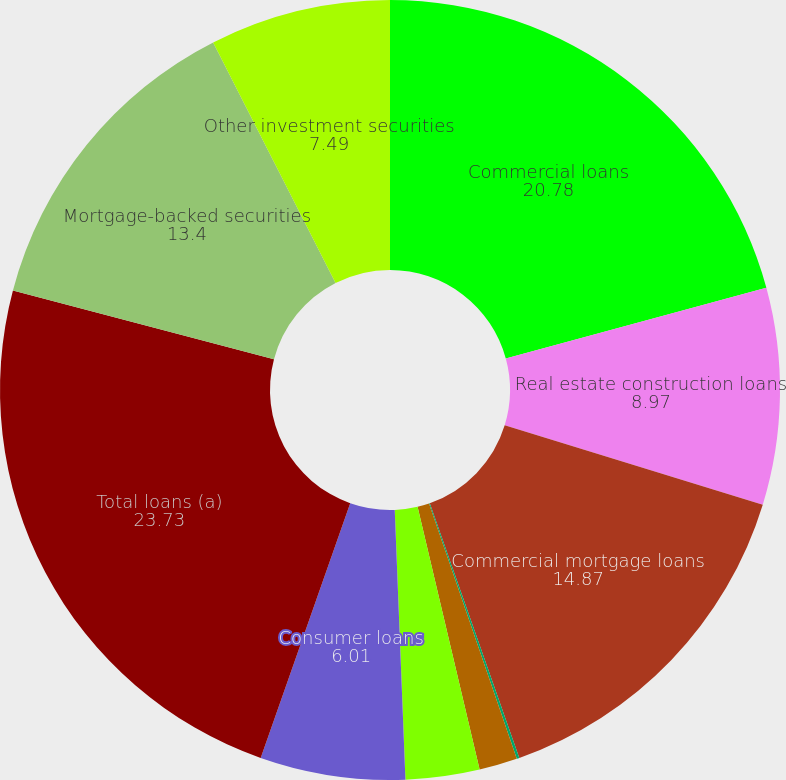Convert chart to OTSL. <chart><loc_0><loc_0><loc_500><loc_500><pie_chart><fcel>Commercial loans<fcel>Real estate construction loans<fcel>Commercial mortgage loans<fcel>Lease financing<fcel>International loans<fcel>Residential mortgage loans<fcel>Consumer loans<fcel>Total loans (a)<fcel>Mortgage-backed securities<fcel>Other investment securities<nl><fcel>20.78%<fcel>8.97%<fcel>14.87%<fcel>0.11%<fcel>1.58%<fcel>3.06%<fcel>6.01%<fcel>23.73%<fcel>13.4%<fcel>7.49%<nl></chart> 